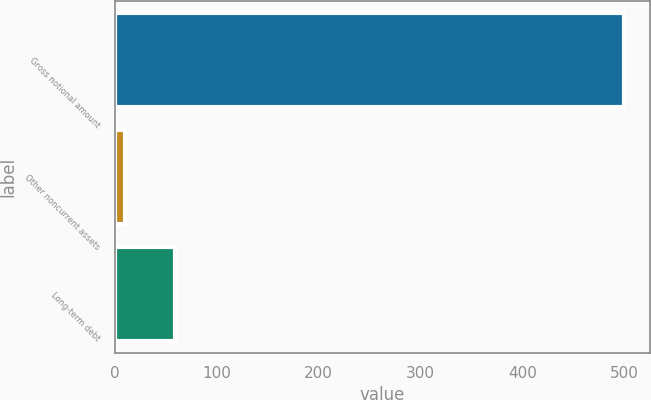<chart> <loc_0><loc_0><loc_500><loc_500><bar_chart><fcel>Gross notional amount<fcel>Other noncurrent assets<fcel>Long-term debt<nl><fcel>500<fcel>10<fcel>59<nl></chart> 